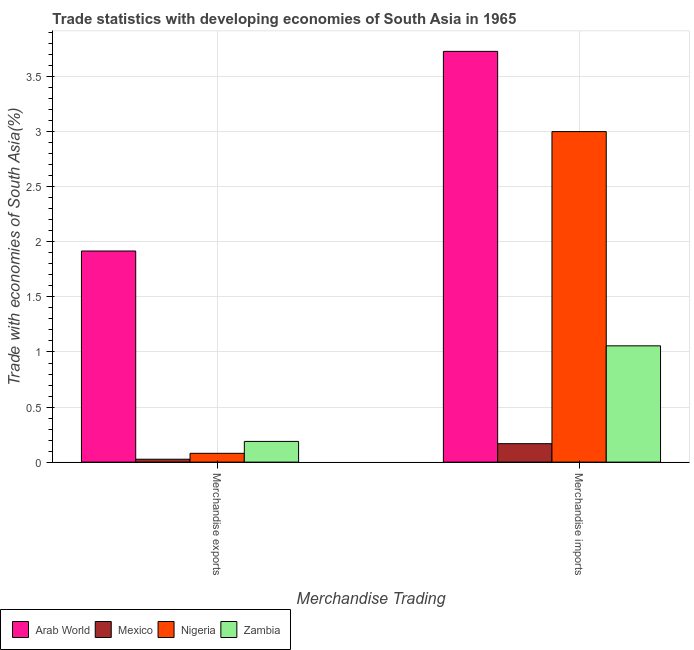How many groups of bars are there?
Offer a terse response. 2. How many bars are there on the 2nd tick from the left?
Your answer should be very brief. 4. What is the merchandise exports in Mexico?
Keep it short and to the point. 0.03. Across all countries, what is the maximum merchandise exports?
Give a very brief answer. 1.92. Across all countries, what is the minimum merchandise imports?
Offer a terse response. 0.17. In which country was the merchandise imports maximum?
Make the answer very short. Arab World. What is the total merchandise imports in the graph?
Provide a succinct answer. 7.95. What is the difference between the merchandise exports in Zambia and that in Nigeria?
Provide a succinct answer. 0.11. What is the difference between the merchandise imports in Arab World and the merchandise exports in Nigeria?
Offer a terse response. 3.65. What is the average merchandise imports per country?
Your response must be concise. 1.99. What is the difference between the merchandise exports and merchandise imports in Arab World?
Offer a terse response. -1.81. In how many countries, is the merchandise imports greater than 1.2 %?
Your answer should be compact. 2. What is the ratio of the merchandise exports in Nigeria to that in Arab World?
Provide a short and direct response. 0.04. Is the merchandise imports in Nigeria less than that in Mexico?
Offer a very short reply. No. In how many countries, is the merchandise imports greater than the average merchandise imports taken over all countries?
Give a very brief answer. 2. What does the 2nd bar from the left in Merchandise imports represents?
Your answer should be very brief. Mexico. What does the 1st bar from the right in Merchandise exports represents?
Ensure brevity in your answer.  Zambia. Where does the legend appear in the graph?
Offer a terse response. Bottom left. What is the title of the graph?
Give a very brief answer. Trade statistics with developing economies of South Asia in 1965. What is the label or title of the X-axis?
Your answer should be compact. Merchandise Trading. What is the label or title of the Y-axis?
Your answer should be compact. Trade with economies of South Asia(%). What is the Trade with economies of South Asia(%) of Arab World in Merchandise exports?
Keep it short and to the point. 1.92. What is the Trade with economies of South Asia(%) in Mexico in Merchandise exports?
Ensure brevity in your answer.  0.03. What is the Trade with economies of South Asia(%) in Nigeria in Merchandise exports?
Offer a very short reply. 0.08. What is the Trade with economies of South Asia(%) of Zambia in Merchandise exports?
Provide a succinct answer. 0.19. What is the Trade with economies of South Asia(%) in Arab World in Merchandise imports?
Give a very brief answer. 3.73. What is the Trade with economies of South Asia(%) in Mexico in Merchandise imports?
Your response must be concise. 0.17. What is the Trade with economies of South Asia(%) in Nigeria in Merchandise imports?
Give a very brief answer. 3. What is the Trade with economies of South Asia(%) in Zambia in Merchandise imports?
Your answer should be very brief. 1.06. Across all Merchandise Trading, what is the maximum Trade with economies of South Asia(%) in Arab World?
Provide a short and direct response. 3.73. Across all Merchandise Trading, what is the maximum Trade with economies of South Asia(%) in Mexico?
Offer a very short reply. 0.17. Across all Merchandise Trading, what is the maximum Trade with economies of South Asia(%) in Nigeria?
Your response must be concise. 3. Across all Merchandise Trading, what is the maximum Trade with economies of South Asia(%) of Zambia?
Ensure brevity in your answer.  1.06. Across all Merchandise Trading, what is the minimum Trade with economies of South Asia(%) of Arab World?
Offer a very short reply. 1.92. Across all Merchandise Trading, what is the minimum Trade with economies of South Asia(%) in Mexico?
Keep it short and to the point. 0.03. Across all Merchandise Trading, what is the minimum Trade with economies of South Asia(%) in Nigeria?
Ensure brevity in your answer.  0.08. Across all Merchandise Trading, what is the minimum Trade with economies of South Asia(%) of Zambia?
Your answer should be very brief. 0.19. What is the total Trade with economies of South Asia(%) of Arab World in the graph?
Offer a terse response. 5.65. What is the total Trade with economies of South Asia(%) of Mexico in the graph?
Offer a very short reply. 0.19. What is the total Trade with economies of South Asia(%) in Nigeria in the graph?
Provide a succinct answer. 3.08. What is the total Trade with economies of South Asia(%) in Zambia in the graph?
Provide a short and direct response. 1.24. What is the difference between the Trade with economies of South Asia(%) in Arab World in Merchandise exports and that in Merchandise imports?
Your answer should be very brief. -1.81. What is the difference between the Trade with economies of South Asia(%) in Mexico in Merchandise exports and that in Merchandise imports?
Your answer should be very brief. -0.14. What is the difference between the Trade with economies of South Asia(%) in Nigeria in Merchandise exports and that in Merchandise imports?
Offer a very short reply. -2.92. What is the difference between the Trade with economies of South Asia(%) in Zambia in Merchandise exports and that in Merchandise imports?
Ensure brevity in your answer.  -0.87. What is the difference between the Trade with economies of South Asia(%) of Arab World in Merchandise exports and the Trade with economies of South Asia(%) of Mexico in Merchandise imports?
Ensure brevity in your answer.  1.75. What is the difference between the Trade with economies of South Asia(%) of Arab World in Merchandise exports and the Trade with economies of South Asia(%) of Nigeria in Merchandise imports?
Your answer should be very brief. -1.08. What is the difference between the Trade with economies of South Asia(%) of Arab World in Merchandise exports and the Trade with economies of South Asia(%) of Zambia in Merchandise imports?
Your answer should be very brief. 0.86. What is the difference between the Trade with economies of South Asia(%) in Mexico in Merchandise exports and the Trade with economies of South Asia(%) in Nigeria in Merchandise imports?
Provide a succinct answer. -2.97. What is the difference between the Trade with economies of South Asia(%) in Mexico in Merchandise exports and the Trade with economies of South Asia(%) in Zambia in Merchandise imports?
Provide a short and direct response. -1.03. What is the difference between the Trade with economies of South Asia(%) of Nigeria in Merchandise exports and the Trade with economies of South Asia(%) of Zambia in Merchandise imports?
Your answer should be very brief. -0.98. What is the average Trade with economies of South Asia(%) in Arab World per Merchandise Trading?
Your response must be concise. 2.82. What is the average Trade with economies of South Asia(%) in Mexico per Merchandise Trading?
Make the answer very short. 0.1. What is the average Trade with economies of South Asia(%) in Nigeria per Merchandise Trading?
Make the answer very short. 1.54. What is the average Trade with economies of South Asia(%) of Zambia per Merchandise Trading?
Your response must be concise. 0.62. What is the difference between the Trade with economies of South Asia(%) of Arab World and Trade with economies of South Asia(%) of Mexico in Merchandise exports?
Offer a very short reply. 1.89. What is the difference between the Trade with economies of South Asia(%) in Arab World and Trade with economies of South Asia(%) in Nigeria in Merchandise exports?
Your answer should be compact. 1.84. What is the difference between the Trade with economies of South Asia(%) of Arab World and Trade with economies of South Asia(%) of Zambia in Merchandise exports?
Provide a succinct answer. 1.73. What is the difference between the Trade with economies of South Asia(%) in Mexico and Trade with economies of South Asia(%) in Nigeria in Merchandise exports?
Keep it short and to the point. -0.05. What is the difference between the Trade with economies of South Asia(%) in Mexico and Trade with economies of South Asia(%) in Zambia in Merchandise exports?
Ensure brevity in your answer.  -0.16. What is the difference between the Trade with economies of South Asia(%) of Nigeria and Trade with economies of South Asia(%) of Zambia in Merchandise exports?
Keep it short and to the point. -0.11. What is the difference between the Trade with economies of South Asia(%) of Arab World and Trade with economies of South Asia(%) of Mexico in Merchandise imports?
Offer a terse response. 3.56. What is the difference between the Trade with economies of South Asia(%) of Arab World and Trade with economies of South Asia(%) of Nigeria in Merchandise imports?
Offer a terse response. 0.73. What is the difference between the Trade with economies of South Asia(%) in Arab World and Trade with economies of South Asia(%) in Zambia in Merchandise imports?
Give a very brief answer. 2.67. What is the difference between the Trade with economies of South Asia(%) of Mexico and Trade with economies of South Asia(%) of Nigeria in Merchandise imports?
Offer a very short reply. -2.83. What is the difference between the Trade with economies of South Asia(%) of Mexico and Trade with economies of South Asia(%) of Zambia in Merchandise imports?
Offer a very short reply. -0.89. What is the difference between the Trade with economies of South Asia(%) in Nigeria and Trade with economies of South Asia(%) in Zambia in Merchandise imports?
Offer a terse response. 1.95. What is the ratio of the Trade with economies of South Asia(%) of Arab World in Merchandise exports to that in Merchandise imports?
Offer a terse response. 0.51. What is the ratio of the Trade with economies of South Asia(%) of Mexico in Merchandise exports to that in Merchandise imports?
Offer a terse response. 0.16. What is the ratio of the Trade with economies of South Asia(%) of Nigeria in Merchandise exports to that in Merchandise imports?
Keep it short and to the point. 0.03. What is the ratio of the Trade with economies of South Asia(%) of Zambia in Merchandise exports to that in Merchandise imports?
Offer a very short reply. 0.18. What is the difference between the highest and the second highest Trade with economies of South Asia(%) of Arab World?
Make the answer very short. 1.81. What is the difference between the highest and the second highest Trade with economies of South Asia(%) in Mexico?
Offer a terse response. 0.14. What is the difference between the highest and the second highest Trade with economies of South Asia(%) in Nigeria?
Your response must be concise. 2.92. What is the difference between the highest and the second highest Trade with economies of South Asia(%) of Zambia?
Offer a terse response. 0.87. What is the difference between the highest and the lowest Trade with economies of South Asia(%) of Arab World?
Your answer should be very brief. 1.81. What is the difference between the highest and the lowest Trade with economies of South Asia(%) of Mexico?
Make the answer very short. 0.14. What is the difference between the highest and the lowest Trade with economies of South Asia(%) in Nigeria?
Your response must be concise. 2.92. What is the difference between the highest and the lowest Trade with economies of South Asia(%) in Zambia?
Your answer should be compact. 0.87. 